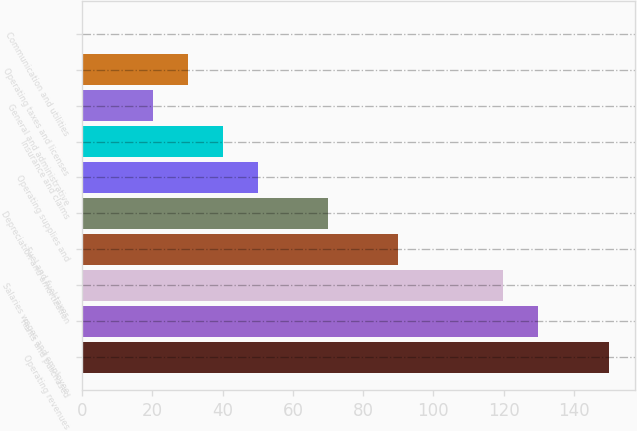Convert chart to OTSL. <chart><loc_0><loc_0><loc_500><loc_500><bar_chart><fcel>Operating revenues<fcel>Rents and purchased<fcel>Salaries wages and employee<fcel>Fuel and fuel taxes<fcel>Depreciation and amortization<fcel>Operating supplies and<fcel>Insurance and claims<fcel>General and administrative<fcel>Operating taxes and licenses<fcel>Communication and utilities<nl><fcel>149.85<fcel>129.91<fcel>119.94<fcel>90.03<fcel>70.09<fcel>50.15<fcel>40.18<fcel>20.24<fcel>30.21<fcel>0.3<nl></chart> 